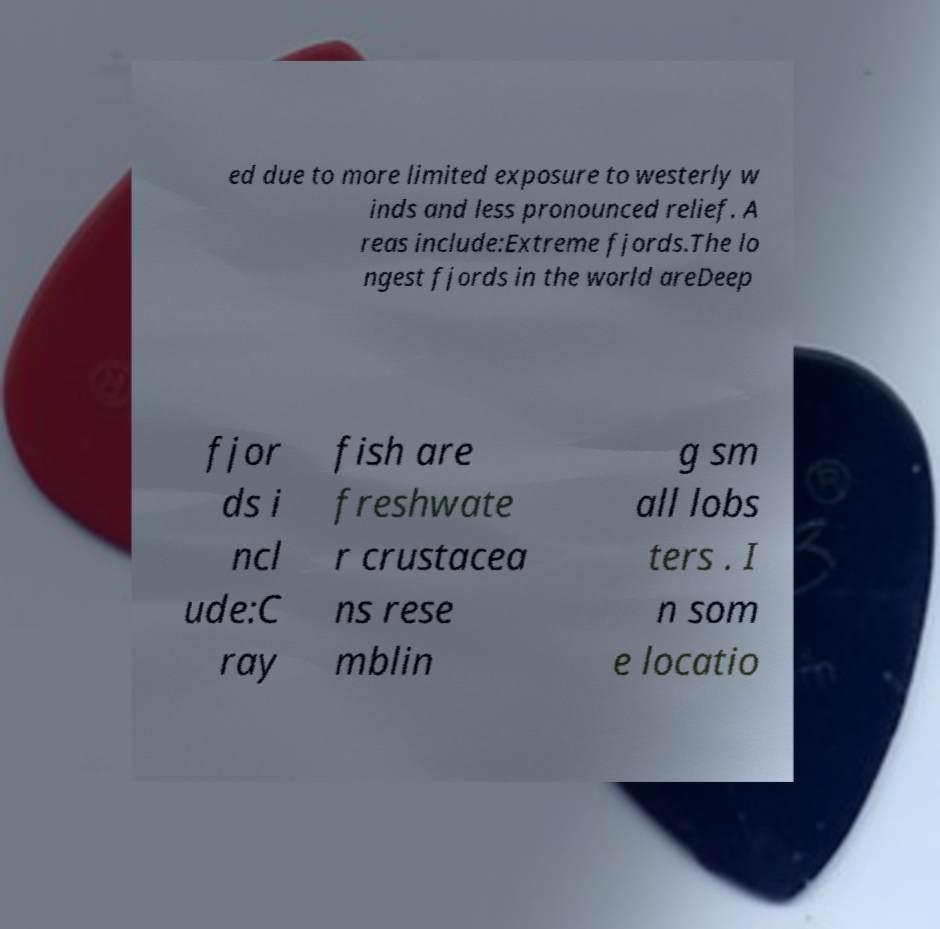Could you extract and type out the text from this image? ed due to more limited exposure to westerly w inds and less pronounced relief. A reas include:Extreme fjords.The lo ngest fjords in the world areDeep fjor ds i ncl ude:C ray fish are freshwate r crustacea ns rese mblin g sm all lobs ters . I n som e locatio 